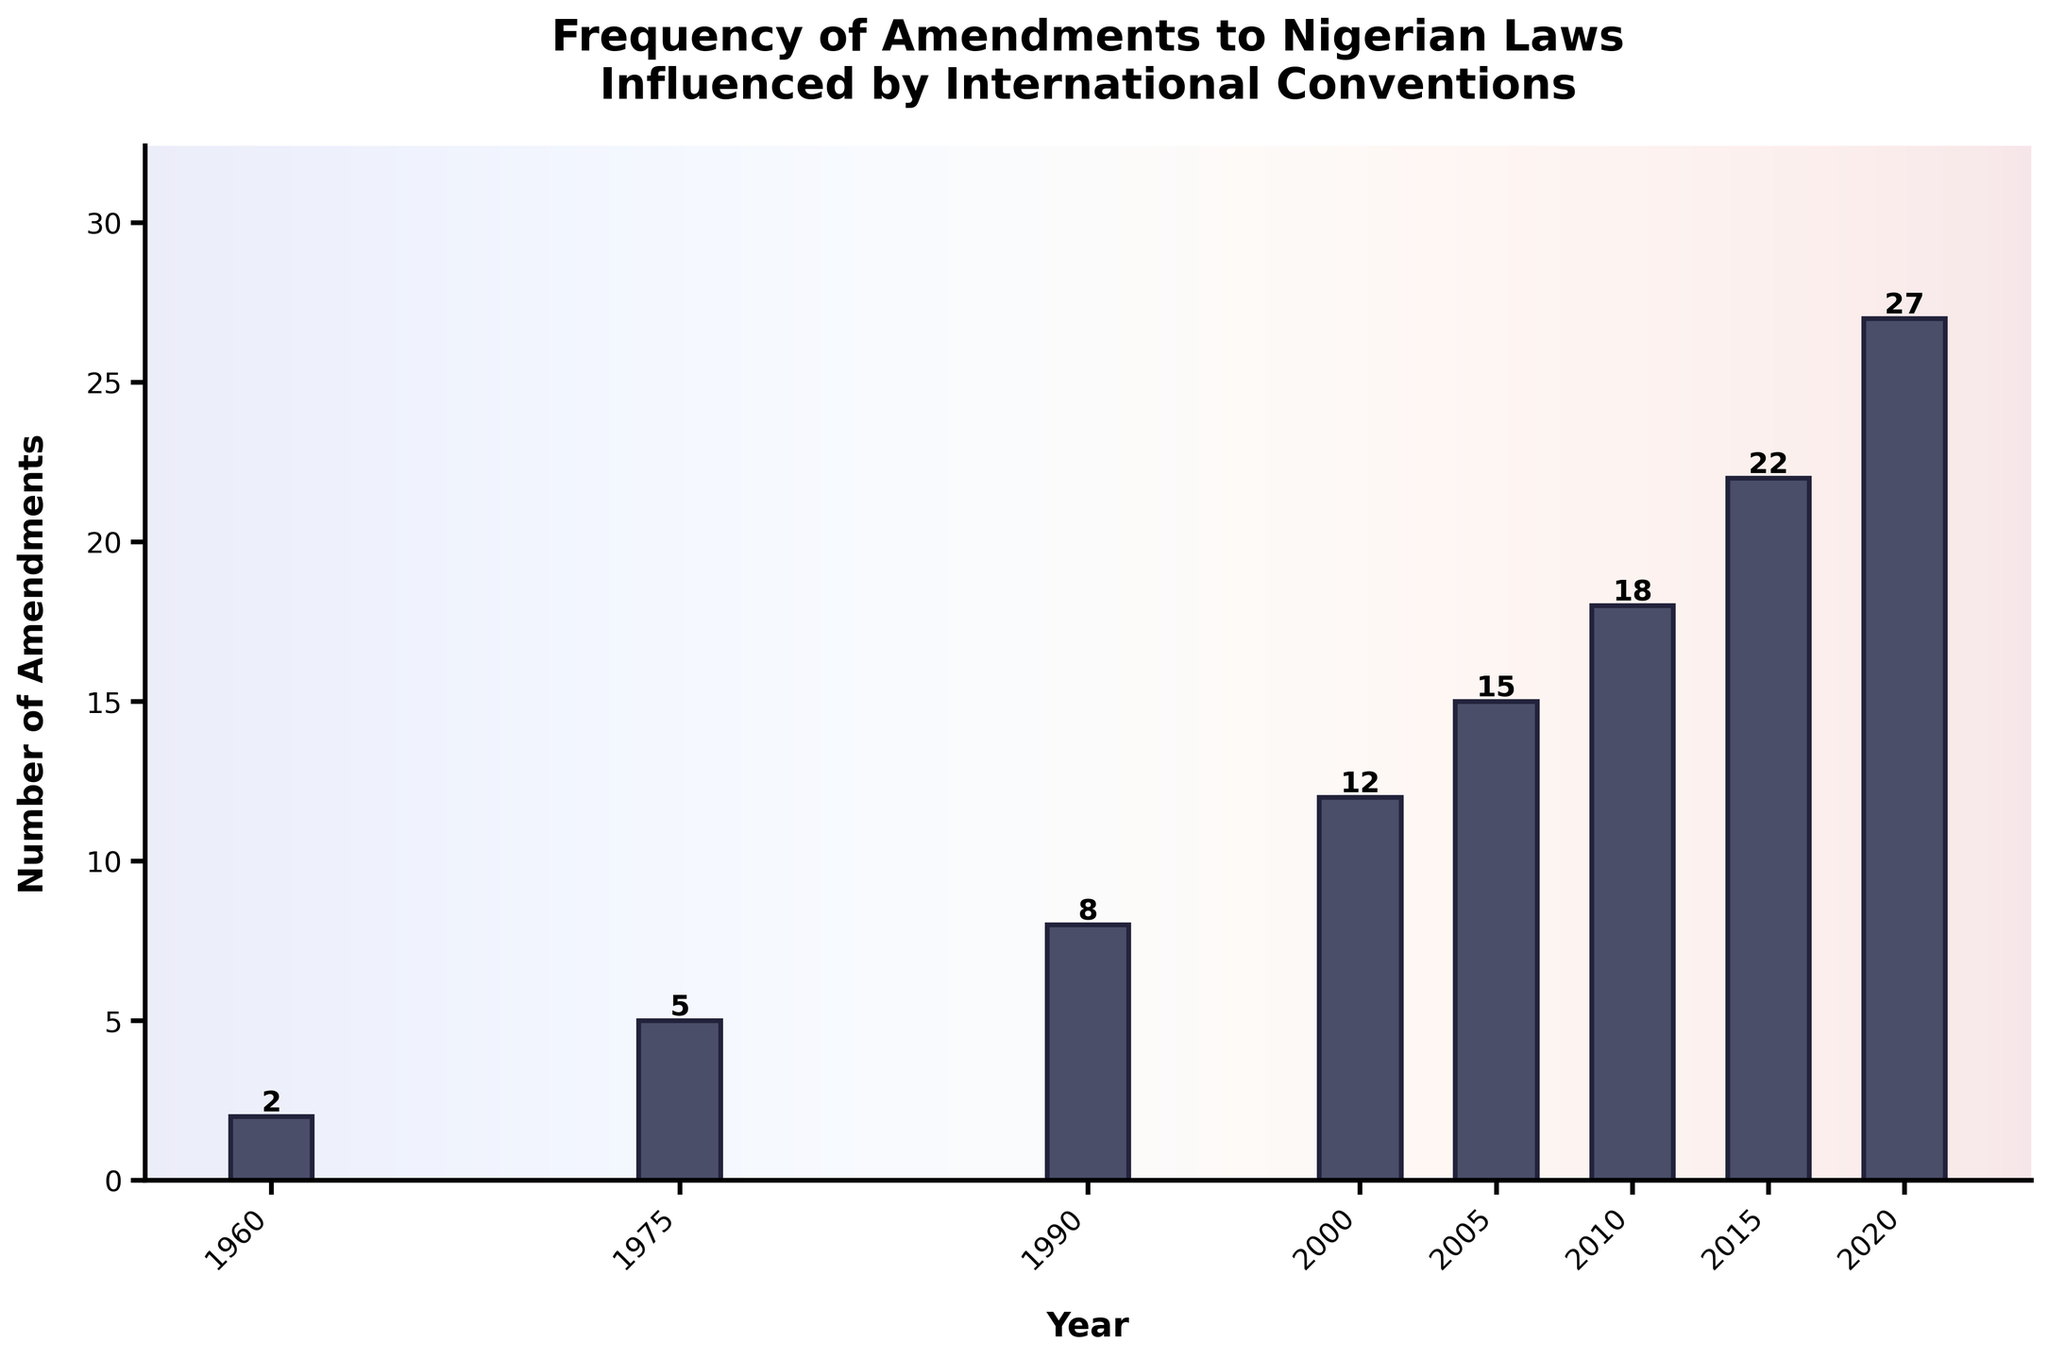How many amendments were made to Nigerian laws influenced by international conventions in 2005? According to the chart, the bar for the year 2005 reaches the value on the y-axis labeled 15.
Answer: 15 Which year had the highest number of amendments? By observing the height of the bars, the year 2020 has the tallest bar, indicating the highest number of amendments at 27.
Answer: 2020 How did the number of amendments change between 2000 and 2005? The bar for 2000 is at 12 amendments, and the bar for 2005 is at 15 amendments. The difference is 15 - 12 = 3.
Answer: Increased by 3 What is the average number of amendments made from 1960 to 2020? The sum of amendments for the years listed is 2 + 5 + 8 + 12 + 15 + 18 + 22 + 27 = 109. There are 8 data points. The average is 109/8 = 13.625.
Answer: 13.625 Which period saw the most significant increase in amendments from one year to the next, and by how much? By comparing consecutive years: 1960-1975 (5-2=3), 1975-1990 (8-5=3), 1990-2000 (12-8=4), 2000-2005 (15-12=3), 2005-2010 (18-15=3), 2010-2015 (22-18=4), 2015-2020 (27-22=5). The period 2015-2020 saw the largest increase of 5 amendments.
Answer: 2015-2020, by 5 amendments Compare the amendments between 1990 and 2010. How many more were made in 2010? The number of amendments in 1990 is 8 and in 2010 is 18. The difference is 18 - 8 = 10.
Answer: 10 more amendments What trend can be observed in the frequency of amendments from 1960 to 2020? The bar heights show a general upward trend, indicating an increase in the frequency of amendments over time.
Answer: Upward trend Is there any year where the number of amendments is exactly double that of the previous year? Comparing consecutive years: None of the amendments are exactly double the previous year's amendments.
Answer: No Which two consecutive decades had the smallest increase in the number of amendments? Checking each pair: 1960-1975 (5-2=3), 1975-1990 (8-5=3), 1990-2000 (12-8=4), 2000-2005 (15-12=3), 2005-2010 (18-15=3), 2010-2015 (22-18=4), 2015-2020 (27-22=5). The smallest increases are between 1960-1975, 1975-1990, 2000-2005, and 2005-2010, each with an increase of 3 amendments.
Answer: 1960-1975, 1975-1990, 2000-2005, 2005-2010 with an increase of 3 amendments each 